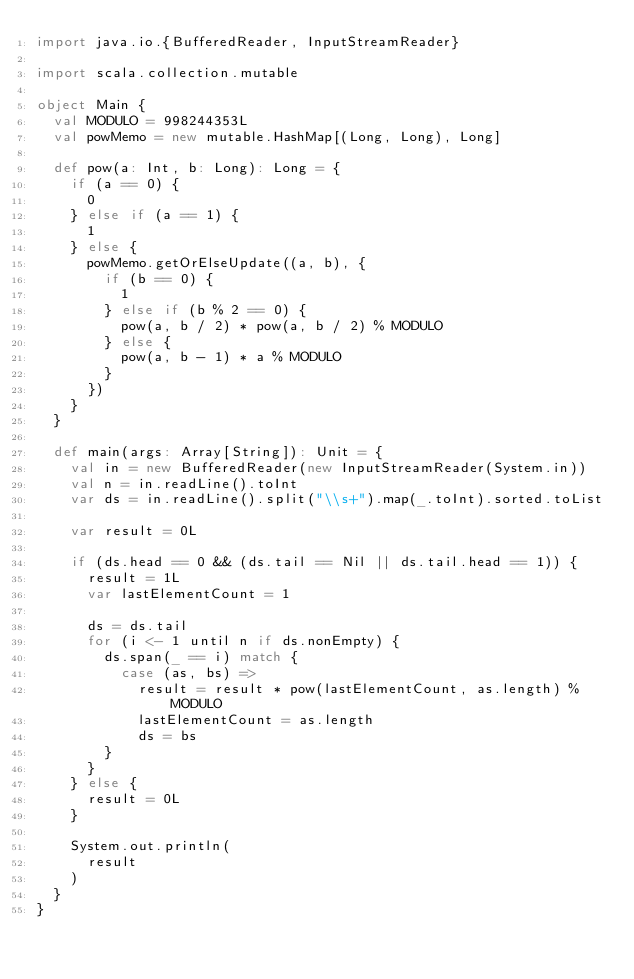<code> <loc_0><loc_0><loc_500><loc_500><_Scala_>import java.io.{BufferedReader, InputStreamReader}

import scala.collection.mutable

object Main {
  val MODULO = 998244353L
  val powMemo = new mutable.HashMap[(Long, Long), Long]

  def pow(a: Int, b: Long): Long = {
    if (a == 0) {
      0
    } else if (a == 1) {
      1
    } else {
      powMemo.getOrElseUpdate((a, b), {
        if (b == 0) {
          1
        } else if (b % 2 == 0) {
          pow(a, b / 2) * pow(a, b / 2) % MODULO
        } else {
          pow(a, b - 1) * a % MODULO
        }
      })
    }
  }

  def main(args: Array[String]): Unit = {
    val in = new BufferedReader(new InputStreamReader(System.in))
    val n = in.readLine().toInt
    var ds = in.readLine().split("\\s+").map(_.toInt).sorted.toList

    var result = 0L

    if (ds.head == 0 && (ds.tail == Nil || ds.tail.head == 1)) {
      result = 1L
      var lastElementCount = 1

      ds = ds.tail
      for (i <- 1 until n if ds.nonEmpty) {
        ds.span(_ == i) match {
          case (as, bs) =>
            result = result * pow(lastElementCount, as.length) % MODULO
            lastElementCount = as.length
            ds = bs
        }
      }
    } else {
      result = 0L
    }

    System.out.println(
      result
    )
  }
}
</code> 